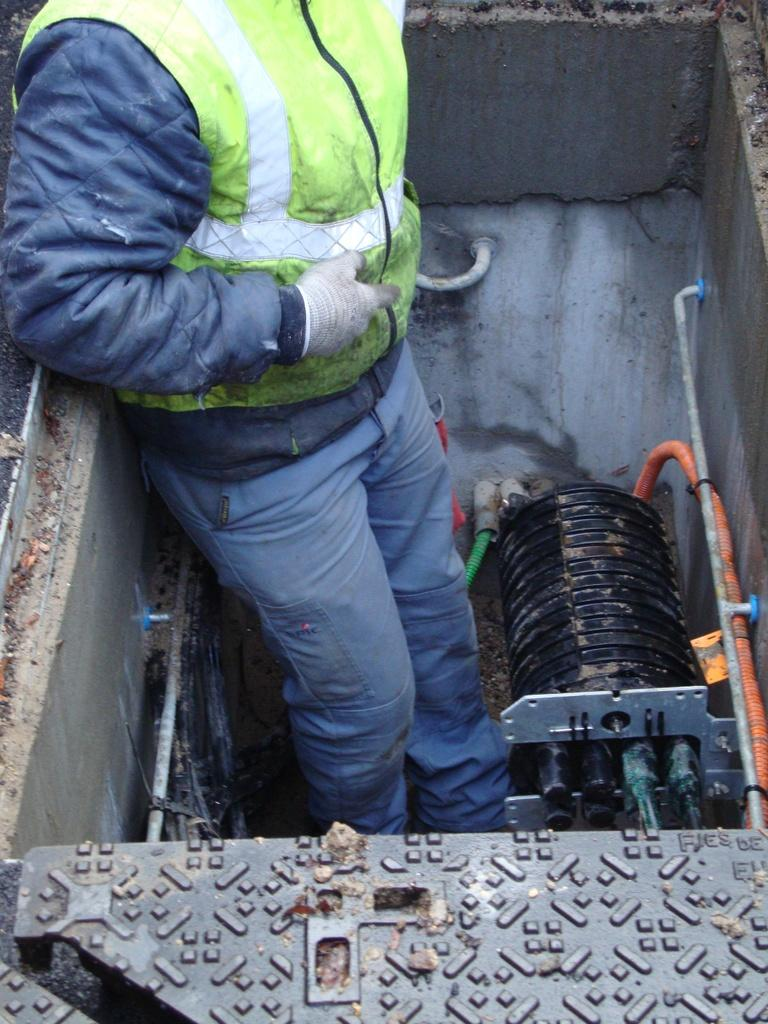Who or what is in the center of the image? There is a person in the center of the image. What is located beside the person? There is a machine beside the person. What is at the bottom of the image? There is a board at the bottom of the image. What can be seen in the background of the image? There is a wall and pipes visible in the background of the image. What type of brake is being used by the person in the image? There is no mention of a brake in the image. 